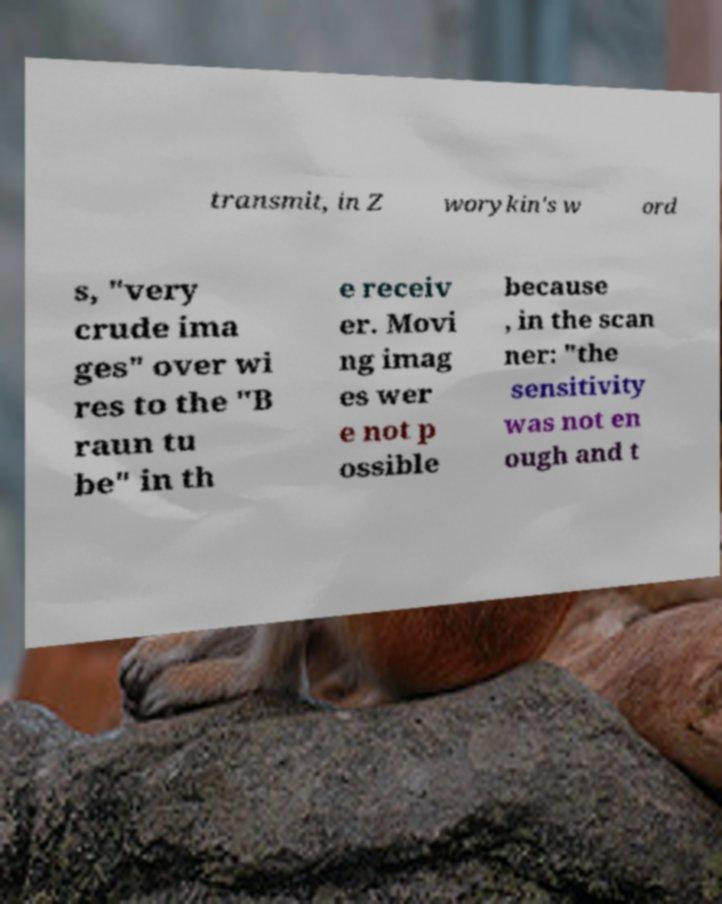Please identify and transcribe the text found in this image. transmit, in Z worykin's w ord s, "very crude ima ges" over wi res to the "B raun tu be" in th e receiv er. Movi ng imag es wer e not p ossible because , in the scan ner: "the sensitivity was not en ough and t 